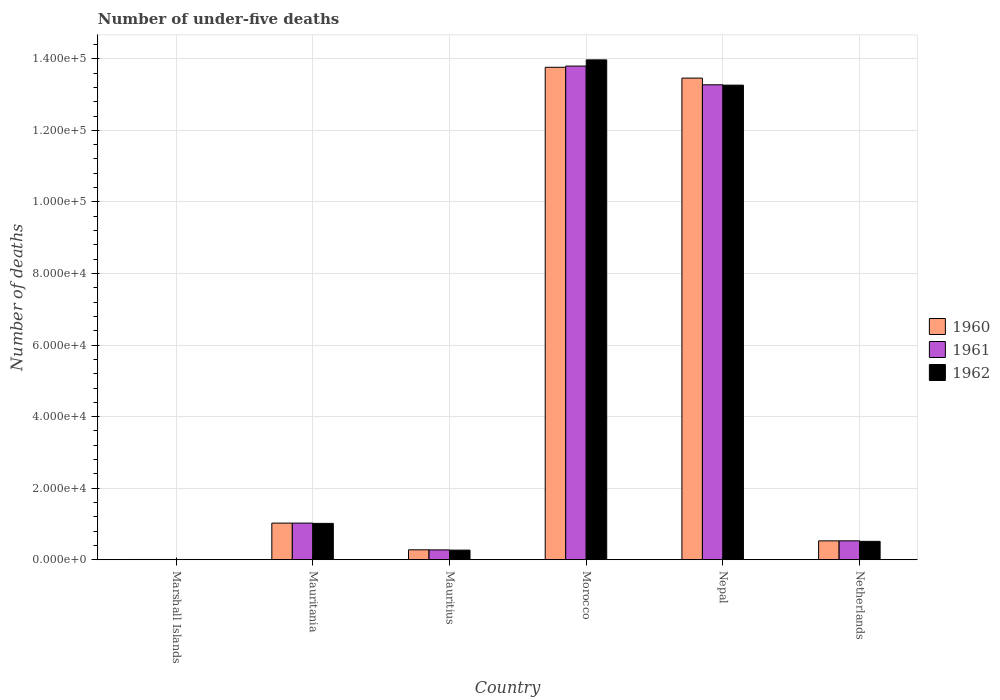How many groups of bars are there?
Give a very brief answer. 6. Are the number of bars per tick equal to the number of legend labels?
Provide a succinct answer. Yes. How many bars are there on the 1st tick from the right?
Give a very brief answer. 3. What is the label of the 5th group of bars from the left?
Your answer should be compact. Nepal. Across all countries, what is the maximum number of under-five deaths in 1960?
Give a very brief answer. 1.38e+05. Across all countries, what is the minimum number of under-five deaths in 1962?
Keep it short and to the point. 78. In which country was the number of under-five deaths in 1961 maximum?
Your answer should be very brief. Morocco. In which country was the number of under-five deaths in 1962 minimum?
Your answer should be compact. Marshall Islands. What is the total number of under-five deaths in 1960 in the graph?
Give a very brief answer. 2.91e+05. What is the difference between the number of under-five deaths in 1962 in Mauritius and that in Nepal?
Offer a very short reply. -1.30e+05. What is the difference between the number of under-five deaths in 1960 in Mauritius and the number of under-five deaths in 1961 in Marshall Islands?
Make the answer very short. 2706. What is the average number of under-five deaths in 1962 per country?
Keep it short and to the point. 4.84e+04. What is the difference between the number of under-five deaths of/in 1961 and number of under-five deaths of/in 1962 in Morocco?
Offer a terse response. -1735. In how many countries, is the number of under-five deaths in 1960 greater than 116000?
Offer a very short reply. 2. What is the ratio of the number of under-five deaths in 1962 in Mauritius to that in Nepal?
Your answer should be compact. 0.02. Is the number of under-five deaths in 1960 in Morocco less than that in Nepal?
Keep it short and to the point. No. What is the difference between the highest and the second highest number of under-five deaths in 1962?
Offer a very short reply. 1.22e+05. What is the difference between the highest and the lowest number of under-five deaths in 1962?
Give a very brief answer. 1.40e+05. Is the sum of the number of under-five deaths in 1962 in Marshall Islands and Netherlands greater than the maximum number of under-five deaths in 1960 across all countries?
Provide a short and direct response. No. What does the 1st bar from the right in Morocco represents?
Provide a short and direct response. 1962. Is it the case that in every country, the sum of the number of under-five deaths in 1960 and number of under-five deaths in 1962 is greater than the number of under-five deaths in 1961?
Provide a succinct answer. Yes. How many bars are there?
Make the answer very short. 18. Are all the bars in the graph horizontal?
Make the answer very short. No. Does the graph contain any zero values?
Offer a terse response. No. What is the title of the graph?
Provide a succinct answer. Number of under-five deaths. What is the label or title of the X-axis?
Ensure brevity in your answer.  Country. What is the label or title of the Y-axis?
Your answer should be compact. Number of deaths. What is the Number of deaths of 1960 in Marshall Islands?
Keep it short and to the point. 81. What is the Number of deaths in 1961 in Marshall Islands?
Your response must be concise. 79. What is the Number of deaths in 1960 in Mauritania?
Provide a short and direct response. 1.02e+04. What is the Number of deaths in 1961 in Mauritania?
Offer a terse response. 1.02e+04. What is the Number of deaths of 1962 in Mauritania?
Provide a short and direct response. 1.02e+04. What is the Number of deaths in 1960 in Mauritius?
Your response must be concise. 2785. What is the Number of deaths of 1961 in Mauritius?
Your answer should be compact. 2762. What is the Number of deaths in 1962 in Mauritius?
Your answer should be compact. 2697. What is the Number of deaths in 1960 in Morocco?
Offer a terse response. 1.38e+05. What is the Number of deaths of 1961 in Morocco?
Give a very brief answer. 1.38e+05. What is the Number of deaths in 1962 in Morocco?
Offer a terse response. 1.40e+05. What is the Number of deaths in 1960 in Nepal?
Your response must be concise. 1.35e+05. What is the Number of deaths in 1961 in Nepal?
Offer a terse response. 1.33e+05. What is the Number of deaths in 1962 in Nepal?
Provide a short and direct response. 1.33e+05. What is the Number of deaths of 1960 in Netherlands?
Your answer should be very brief. 5281. What is the Number of deaths of 1961 in Netherlands?
Offer a terse response. 5288. What is the Number of deaths of 1962 in Netherlands?
Offer a very short reply. 5152. Across all countries, what is the maximum Number of deaths in 1960?
Your response must be concise. 1.38e+05. Across all countries, what is the maximum Number of deaths of 1961?
Ensure brevity in your answer.  1.38e+05. Across all countries, what is the maximum Number of deaths of 1962?
Your response must be concise. 1.40e+05. Across all countries, what is the minimum Number of deaths of 1961?
Give a very brief answer. 79. What is the total Number of deaths of 1960 in the graph?
Ensure brevity in your answer.  2.91e+05. What is the total Number of deaths of 1961 in the graph?
Your answer should be compact. 2.89e+05. What is the total Number of deaths of 1962 in the graph?
Your answer should be compact. 2.90e+05. What is the difference between the Number of deaths in 1960 in Marshall Islands and that in Mauritania?
Provide a succinct answer. -1.02e+04. What is the difference between the Number of deaths of 1961 in Marshall Islands and that in Mauritania?
Offer a very short reply. -1.02e+04. What is the difference between the Number of deaths in 1962 in Marshall Islands and that in Mauritania?
Offer a terse response. -1.01e+04. What is the difference between the Number of deaths in 1960 in Marshall Islands and that in Mauritius?
Offer a terse response. -2704. What is the difference between the Number of deaths of 1961 in Marshall Islands and that in Mauritius?
Provide a succinct answer. -2683. What is the difference between the Number of deaths in 1962 in Marshall Islands and that in Mauritius?
Offer a terse response. -2619. What is the difference between the Number of deaths of 1960 in Marshall Islands and that in Morocco?
Give a very brief answer. -1.38e+05. What is the difference between the Number of deaths in 1961 in Marshall Islands and that in Morocco?
Ensure brevity in your answer.  -1.38e+05. What is the difference between the Number of deaths in 1962 in Marshall Islands and that in Morocco?
Your response must be concise. -1.40e+05. What is the difference between the Number of deaths in 1960 in Marshall Islands and that in Nepal?
Your response must be concise. -1.35e+05. What is the difference between the Number of deaths in 1961 in Marshall Islands and that in Nepal?
Offer a very short reply. -1.33e+05. What is the difference between the Number of deaths of 1962 in Marshall Islands and that in Nepal?
Keep it short and to the point. -1.33e+05. What is the difference between the Number of deaths of 1960 in Marshall Islands and that in Netherlands?
Ensure brevity in your answer.  -5200. What is the difference between the Number of deaths of 1961 in Marshall Islands and that in Netherlands?
Provide a short and direct response. -5209. What is the difference between the Number of deaths in 1962 in Marshall Islands and that in Netherlands?
Your response must be concise. -5074. What is the difference between the Number of deaths in 1960 in Mauritania and that in Mauritius?
Make the answer very short. 7463. What is the difference between the Number of deaths of 1961 in Mauritania and that in Mauritius?
Provide a succinct answer. 7483. What is the difference between the Number of deaths of 1962 in Mauritania and that in Mauritius?
Provide a short and direct response. 7469. What is the difference between the Number of deaths of 1960 in Mauritania and that in Morocco?
Give a very brief answer. -1.27e+05. What is the difference between the Number of deaths of 1961 in Mauritania and that in Morocco?
Your answer should be very brief. -1.28e+05. What is the difference between the Number of deaths of 1962 in Mauritania and that in Morocco?
Your answer should be compact. -1.30e+05. What is the difference between the Number of deaths of 1960 in Mauritania and that in Nepal?
Offer a very short reply. -1.24e+05. What is the difference between the Number of deaths of 1961 in Mauritania and that in Nepal?
Provide a succinct answer. -1.22e+05. What is the difference between the Number of deaths in 1962 in Mauritania and that in Nepal?
Ensure brevity in your answer.  -1.22e+05. What is the difference between the Number of deaths of 1960 in Mauritania and that in Netherlands?
Keep it short and to the point. 4967. What is the difference between the Number of deaths in 1961 in Mauritania and that in Netherlands?
Make the answer very short. 4957. What is the difference between the Number of deaths in 1962 in Mauritania and that in Netherlands?
Provide a succinct answer. 5014. What is the difference between the Number of deaths in 1960 in Mauritius and that in Morocco?
Provide a succinct answer. -1.35e+05. What is the difference between the Number of deaths of 1961 in Mauritius and that in Morocco?
Offer a terse response. -1.35e+05. What is the difference between the Number of deaths of 1962 in Mauritius and that in Morocco?
Keep it short and to the point. -1.37e+05. What is the difference between the Number of deaths of 1960 in Mauritius and that in Nepal?
Make the answer very short. -1.32e+05. What is the difference between the Number of deaths of 1961 in Mauritius and that in Nepal?
Offer a very short reply. -1.30e+05. What is the difference between the Number of deaths in 1962 in Mauritius and that in Nepal?
Give a very brief answer. -1.30e+05. What is the difference between the Number of deaths of 1960 in Mauritius and that in Netherlands?
Your answer should be very brief. -2496. What is the difference between the Number of deaths of 1961 in Mauritius and that in Netherlands?
Make the answer very short. -2526. What is the difference between the Number of deaths of 1962 in Mauritius and that in Netherlands?
Give a very brief answer. -2455. What is the difference between the Number of deaths of 1960 in Morocco and that in Nepal?
Give a very brief answer. 3019. What is the difference between the Number of deaths of 1961 in Morocco and that in Nepal?
Offer a terse response. 5227. What is the difference between the Number of deaths of 1962 in Morocco and that in Nepal?
Offer a very short reply. 7061. What is the difference between the Number of deaths of 1960 in Morocco and that in Netherlands?
Provide a succinct answer. 1.32e+05. What is the difference between the Number of deaths of 1961 in Morocco and that in Netherlands?
Provide a succinct answer. 1.33e+05. What is the difference between the Number of deaths of 1962 in Morocco and that in Netherlands?
Make the answer very short. 1.35e+05. What is the difference between the Number of deaths in 1960 in Nepal and that in Netherlands?
Give a very brief answer. 1.29e+05. What is the difference between the Number of deaths in 1961 in Nepal and that in Netherlands?
Make the answer very short. 1.27e+05. What is the difference between the Number of deaths in 1962 in Nepal and that in Netherlands?
Offer a very short reply. 1.27e+05. What is the difference between the Number of deaths of 1960 in Marshall Islands and the Number of deaths of 1961 in Mauritania?
Provide a succinct answer. -1.02e+04. What is the difference between the Number of deaths of 1960 in Marshall Islands and the Number of deaths of 1962 in Mauritania?
Provide a succinct answer. -1.01e+04. What is the difference between the Number of deaths in 1961 in Marshall Islands and the Number of deaths in 1962 in Mauritania?
Your answer should be very brief. -1.01e+04. What is the difference between the Number of deaths in 1960 in Marshall Islands and the Number of deaths in 1961 in Mauritius?
Provide a short and direct response. -2681. What is the difference between the Number of deaths of 1960 in Marshall Islands and the Number of deaths of 1962 in Mauritius?
Make the answer very short. -2616. What is the difference between the Number of deaths of 1961 in Marshall Islands and the Number of deaths of 1962 in Mauritius?
Your response must be concise. -2618. What is the difference between the Number of deaths in 1960 in Marshall Islands and the Number of deaths in 1961 in Morocco?
Provide a succinct answer. -1.38e+05. What is the difference between the Number of deaths in 1960 in Marshall Islands and the Number of deaths in 1962 in Morocco?
Ensure brevity in your answer.  -1.40e+05. What is the difference between the Number of deaths in 1961 in Marshall Islands and the Number of deaths in 1962 in Morocco?
Your response must be concise. -1.40e+05. What is the difference between the Number of deaths of 1960 in Marshall Islands and the Number of deaths of 1961 in Nepal?
Keep it short and to the point. -1.33e+05. What is the difference between the Number of deaths of 1960 in Marshall Islands and the Number of deaths of 1962 in Nepal?
Provide a short and direct response. -1.33e+05. What is the difference between the Number of deaths of 1961 in Marshall Islands and the Number of deaths of 1962 in Nepal?
Offer a very short reply. -1.33e+05. What is the difference between the Number of deaths in 1960 in Marshall Islands and the Number of deaths in 1961 in Netherlands?
Give a very brief answer. -5207. What is the difference between the Number of deaths of 1960 in Marshall Islands and the Number of deaths of 1962 in Netherlands?
Make the answer very short. -5071. What is the difference between the Number of deaths of 1961 in Marshall Islands and the Number of deaths of 1962 in Netherlands?
Your response must be concise. -5073. What is the difference between the Number of deaths of 1960 in Mauritania and the Number of deaths of 1961 in Mauritius?
Your answer should be compact. 7486. What is the difference between the Number of deaths in 1960 in Mauritania and the Number of deaths in 1962 in Mauritius?
Provide a succinct answer. 7551. What is the difference between the Number of deaths in 1961 in Mauritania and the Number of deaths in 1962 in Mauritius?
Give a very brief answer. 7548. What is the difference between the Number of deaths in 1960 in Mauritania and the Number of deaths in 1961 in Morocco?
Offer a terse response. -1.28e+05. What is the difference between the Number of deaths in 1960 in Mauritania and the Number of deaths in 1962 in Morocco?
Provide a short and direct response. -1.29e+05. What is the difference between the Number of deaths of 1961 in Mauritania and the Number of deaths of 1962 in Morocco?
Your response must be concise. -1.29e+05. What is the difference between the Number of deaths in 1960 in Mauritania and the Number of deaths in 1961 in Nepal?
Provide a succinct answer. -1.22e+05. What is the difference between the Number of deaths in 1960 in Mauritania and the Number of deaths in 1962 in Nepal?
Provide a succinct answer. -1.22e+05. What is the difference between the Number of deaths in 1961 in Mauritania and the Number of deaths in 1962 in Nepal?
Your answer should be very brief. -1.22e+05. What is the difference between the Number of deaths of 1960 in Mauritania and the Number of deaths of 1961 in Netherlands?
Offer a very short reply. 4960. What is the difference between the Number of deaths in 1960 in Mauritania and the Number of deaths in 1962 in Netherlands?
Your response must be concise. 5096. What is the difference between the Number of deaths of 1961 in Mauritania and the Number of deaths of 1962 in Netherlands?
Your answer should be compact. 5093. What is the difference between the Number of deaths in 1960 in Mauritius and the Number of deaths in 1961 in Morocco?
Your answer should be compact. -1.35e+05. What is the difference between the Number of deaths of 1960 in Mauritius and the Number of deaths of 1962 in Morocco?
Give a very brief answer. -1.37e+05. What is the difference between the Number of deaths of 1961 in Mauritius and the Number of deaths of 1962 in Morocco?
Your answer should be compact. -1.37e+05. What is the difference between the Number of deaths in 1960 in Mauritius and the Number of deaths in 1961 in Nepal?
Your answer should be compact. -1.30e+05. What is the difference between the Number of deaths in 1960 in Mauritius and the Number of deaths in 1962 in Nepal?
Give a very brief answer. -1.30e+05. What is the difference between the Number of deaths of 1961 in Mauritius and the Number of deaths of 1962 in Nepal?
Give a very brief answer. -1.30e+05. What is the difference between the Number of deaths of 1960 in Mauritius and the Number of deaths of 1961 in Netherlands?
Your answer should be compact. -2503. What is the difference between the Number of deaths of 1960 in Mauritius and the Number of deaths of 1962 in Netherlands?
Offer a terse response. -2367. What is the difference between the Number of deaths of 1961 in Mauritius and the Number of deaths of 1962 in Netherlands?
Keep it short and to the point. -2390. What is the difference between the Number of deaths of 1960 in Morocco and the Number of deaths of 1961 in Nepal?
Provide a short and direct response. 4887. What is the difference between the Number of deaths of 1960 in Morocco and the Number of deaths of 1962 in Nepal?
Offer a terse response. 4986. What is the difference between the Number of deaths in 1961 in Morocco and the Number of deaths in 1962 in Nepal?
Make the answer very short. 5326. What is the difference between the Number of deaths of 1960 in Morocco and the Number of deaths of 1961 in Netherlands?
Ensure brevity in your answer.  1.32e+05. What is the difference between the Number of deaths in 1960 in Morocco and the Number of deaths in 1962 in Netherlands?
Offer a terse response. 1.32e+05. What is the difference between the Number of deaths in 1961 in Morocco and the Number of deaths in 1962 in Netherlands?
Offer a terse response. 1.33e+05. What is the difference between the Number of deaths of 1960 in Nepal and the Number of deaths of 1961 in Netherlands?
Your answer should be very brief. 1.29e+05. What is the difference between the Number of deaths of 1960 in Nepal and the Number of deaths of 1962 in Netherlands?
Make the answer very short. 1.29e+05. What is the difference between the Number of deaths in 1961 in Nepal and the Number of deaths in 1962 in Netherlands?
Provide a succinct answer. 1.28e+05. What is the average Number of deaths of 1960 per country?
Give a very brief answer. 4.84e+04. What is the average Number of deaths of 1961 per country?
Your answer should be compact. 4.82e+04. What is the average Number of deaths of 1962 per country?
Your answer should be compact. 4.84e+04. What is the difference between the Number of deaths of 1960 and Number of deaths of 1962 in Marshall Islands?
Provide a succinct answer. 3. What is the difference between the Number of deaths in 1961 and Number of deaths in 1962 in Mauritania?
Offer a very short reply. 79. What is the difference between the Number of deaths of 1961 and Number of deaths of 1962 in Mauritius?
Make the answer very short. 65. What is the difference between the Number of deaths of 1960 and Number of deaths of 1961 in Morocco?
Your answer should be very brief. -340. What is the difference between the Number of deaths of 1960 and Number of deaths of 1962 in Morocco?
Offer a very short reply. -2075. What is the difference between the Number of deaths of 1961 and Number of deaths of 1962 in Morocco?
Your answer should be compact. -1735. What is the difference between the Number of deaths of 1960 and Number of deaths of 1961 in Nepal?
Ensure brevity in your answer.  1868. What is the difference between the Number of deaths of 1960 and Number of deaths of 1962 in Nepal?
Offer a very short reply. 1967. What is the difference between the Number of deaths in 1960 and Number of deaths in 1961 in Netherlands?
Give a very brief answer. -7. What is the difference between the Number of deaths in 1960 and Number of deaths in 1962 in Netherlands?
Make the answer very short. 129. What is the difference between the Number of deaths in 1961 and Number of deaths in 1962 in Netherlands?
Your answer should be very brief. 136. What is the ratio of the Number of deaths of 1960 in Marshall Islands to that in Mauritania?
Offer a terse response. 0.01. What is the ratio of the Number of deaths in 1961 in Marshall Islands to that in Mauritania?
Your answer should be very brief. 0.01. What is the ratio of the Number of deaths of 1962 in Marshall Islands to that in Mauritania?
Keep it short and to the point. 0.01. What is the ratio of the Number of deaths in 1960 in Marshall Islands to that in Mauritius?
Offer a very short reply. 0.03. What is the ratio of the Number of deaths of 1961 in Marshall Islands to that in Mauritius?
Give a very brief answer. 0.03. What is the ratio of the Number of deaths of 1962 in Marshall Islands to that in Mauritius?
Ensure brevity in your answer.  0.03. What is the ratio of the Number of deaths of 1960 in Marshall Islands to that in Morocco?
Keep it short and to the point. 0. What is the ratio of the Number of deaths of 1961 in Marshall Islands to that in Morocco?
Make the answer very short. 0. What is the ratio of the Number of deaths of 1962 in Marshall Islands to that in Morocco?
Your response must be concise. 0. What is the ratio of the Number of deaths of 1960 in Marshall Islands to that in Nepal?
Your answer should be compact. 0. What is the ratio of the Number of deaths in 1961 in Marshall Islands to that in Nepal?
Your response must be concise. 0. What is the ratio of the Number of deaths in 1962 in Marshall Islands to that in Nepal?
Provide a succinct answer. 0. What is the ratio of the Number of deaths in 1960 in Marshall Islands to that in Netherlands?
Provide a succinct answer. 0.02. What is the ratio of the Number of deaths in 1961 in Marshall Islands to that in Netherlands?
Keep it short and to the point. 0.01. What is the ratio of the Number of deaths of 1962 in Marshall Islands to that in Netherlands?
Provide a short and direct response. 0.02. What is the ratio of the Number of deaths of 1960 in Mauritania to that in Mauritius?
Your response must be concise. 3.68. What is the ratio of the Number of deaths of 1961 in Mauritania to that in Mauritius?
Offer a terse response. 3.71. What is the ratio of the Number of deaths in 1962 in Mauritania to that in Mauritius?
Your answer should be very brief. 3.77. What is the ratio of the Number of deaths in 1960 in Mauritania to that in Morocco?
Provide a short and direct response. 0.07. What is the ratio of the Number of deaths in 1961 in Mauritania to that in Morocco?
Provide a short and direct response. 0.07. What is the ratio of the Number of deaths in 1962 in Mauritania to that in Morocco?
Your answer should be very brief. 0.07. What is the ratio of the Number of deaths in 1960 in Mauritania to that in Nepal?
Provide a short and direct response. 0.08. What is the ratio of the Number of deaths in 1961 in Mauritania to that in Nepal?
Your response must be concise. 0.08. What is the ratio of the Number of deaths of 1962 in Mauritania to that in Nepal?
Give a very brief answer. 0.08. What is the ratio of the Number of deaths in 1960 in Mauritania to that in Netherlands?
Your answer should be very brief. 1.94. What is the ratio of the Number of deaths in 1961 in Mauritania to that in Netherlands?
Give a very brief answer. 1.94. What is the ratio of the Number of deaths in 1962 in Mauritania to that in Netherlands?
Offer a very short reply. 1.97. What is the ratio of the Number of deaths in 1960 in Mauritius to that in Morocco?
Provide a short and direct response. 0.02. What is the ratio of the Number of deaths of 1961 in Mauritius to that in Morocco?
Provide a short and direct response. 0.02. What is the ratio of the Number of deaths of 1962 in Mauritius to that in Morocco?
Provide a short and direct response. 0.02. What is the ratio of the Number of deaths of 1960 in Mauritius to that in Nepal?
Provide a short and direct response. 0.02. What is the ratio of the Number of deaths in 1961 in Mauritius to that in Nepal?
Your response must be concise. 0.02. What is the ratio of the Number of deaths in 1962 in Mauritius to that in Nepal?
Provide a short and direct response. 0.02. What is the ratio of the Number of deaths in 1960 in Mauritius to that in Netherlands?
Your answer should be very brief. 0.53. What is the ratio of the Number of deaths in 1961 in Mauritius to that in Netherlands?
Ensure brevity in your answer.  0.52. What is the ratio of the Number of deaths of 1962 in Mauritius to that in Netherlands?
Provide a short and direct response. 0.52. What is the ratio of the Number of deaths in 1960 in Morocco to that in Nepal?
Give a very brief answer. 1.02. What is the ratio of the Number of deaths of 1961 in Morocco to that in Nepal?
Your response must be concise. 1.04. What is the ratio of the Number of deaths in 1962 in Morocco to that in Nepal?
Provide a short and direct response. 1.05. What is the ratio of the Number of deaths of 1960 in Morocco to that in Netherlands?
Your response must be concise. 26.06. What is the ratio of the Number of deaths of 1961 in Morocco to that in Netherlands?
Offer a terse response. 26.09. What is the ratio of the Number of deaths in 1962 in Morocco to that in Netherlands?
Ensure brevity in your answer.  27.12. What is the ratio of the Number of deaths of 1960 in Nepal to that in Netherlands?
Ensure brevity in your answer.  25.49. What is the ratio of the Number of deaths of 1961 in Nepal to that in Netherlands?
Your answer should be very brief. 25.1. What is the ratio of the Number of deaths of 1962 in Nepal to that in Netherlands?
Make the answer very short. 25.75. What is the difference between the highest and the second highest Number of deaths in 1960?
Offer a terse response. 3019. What is the difference between the highest and the second highest Number of deaths of 1961?
Your response must be concise. 5227. What is the difference between the highest and the second highest Number of deaths in 1962?
Keep it short and to the point. 7061. What is the difference between the highest and the lowest Number of deaths in 1960?
Give a very brief answer. 1.38e+05. What is the difference between the highest and the lowest Number of deaths in 1961?
Keep it short and to the point. 1.38e+05. What is the difference between the highest and the lowest Number of deaths in 1962?
Your answer should be compact. 1.40e+05. 